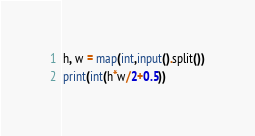<code> <loc_0><loc_0><loc_500><loc_500><_Python_>h, w = map(int,input().split())
print(int(h*w/2+0.5))</code> 